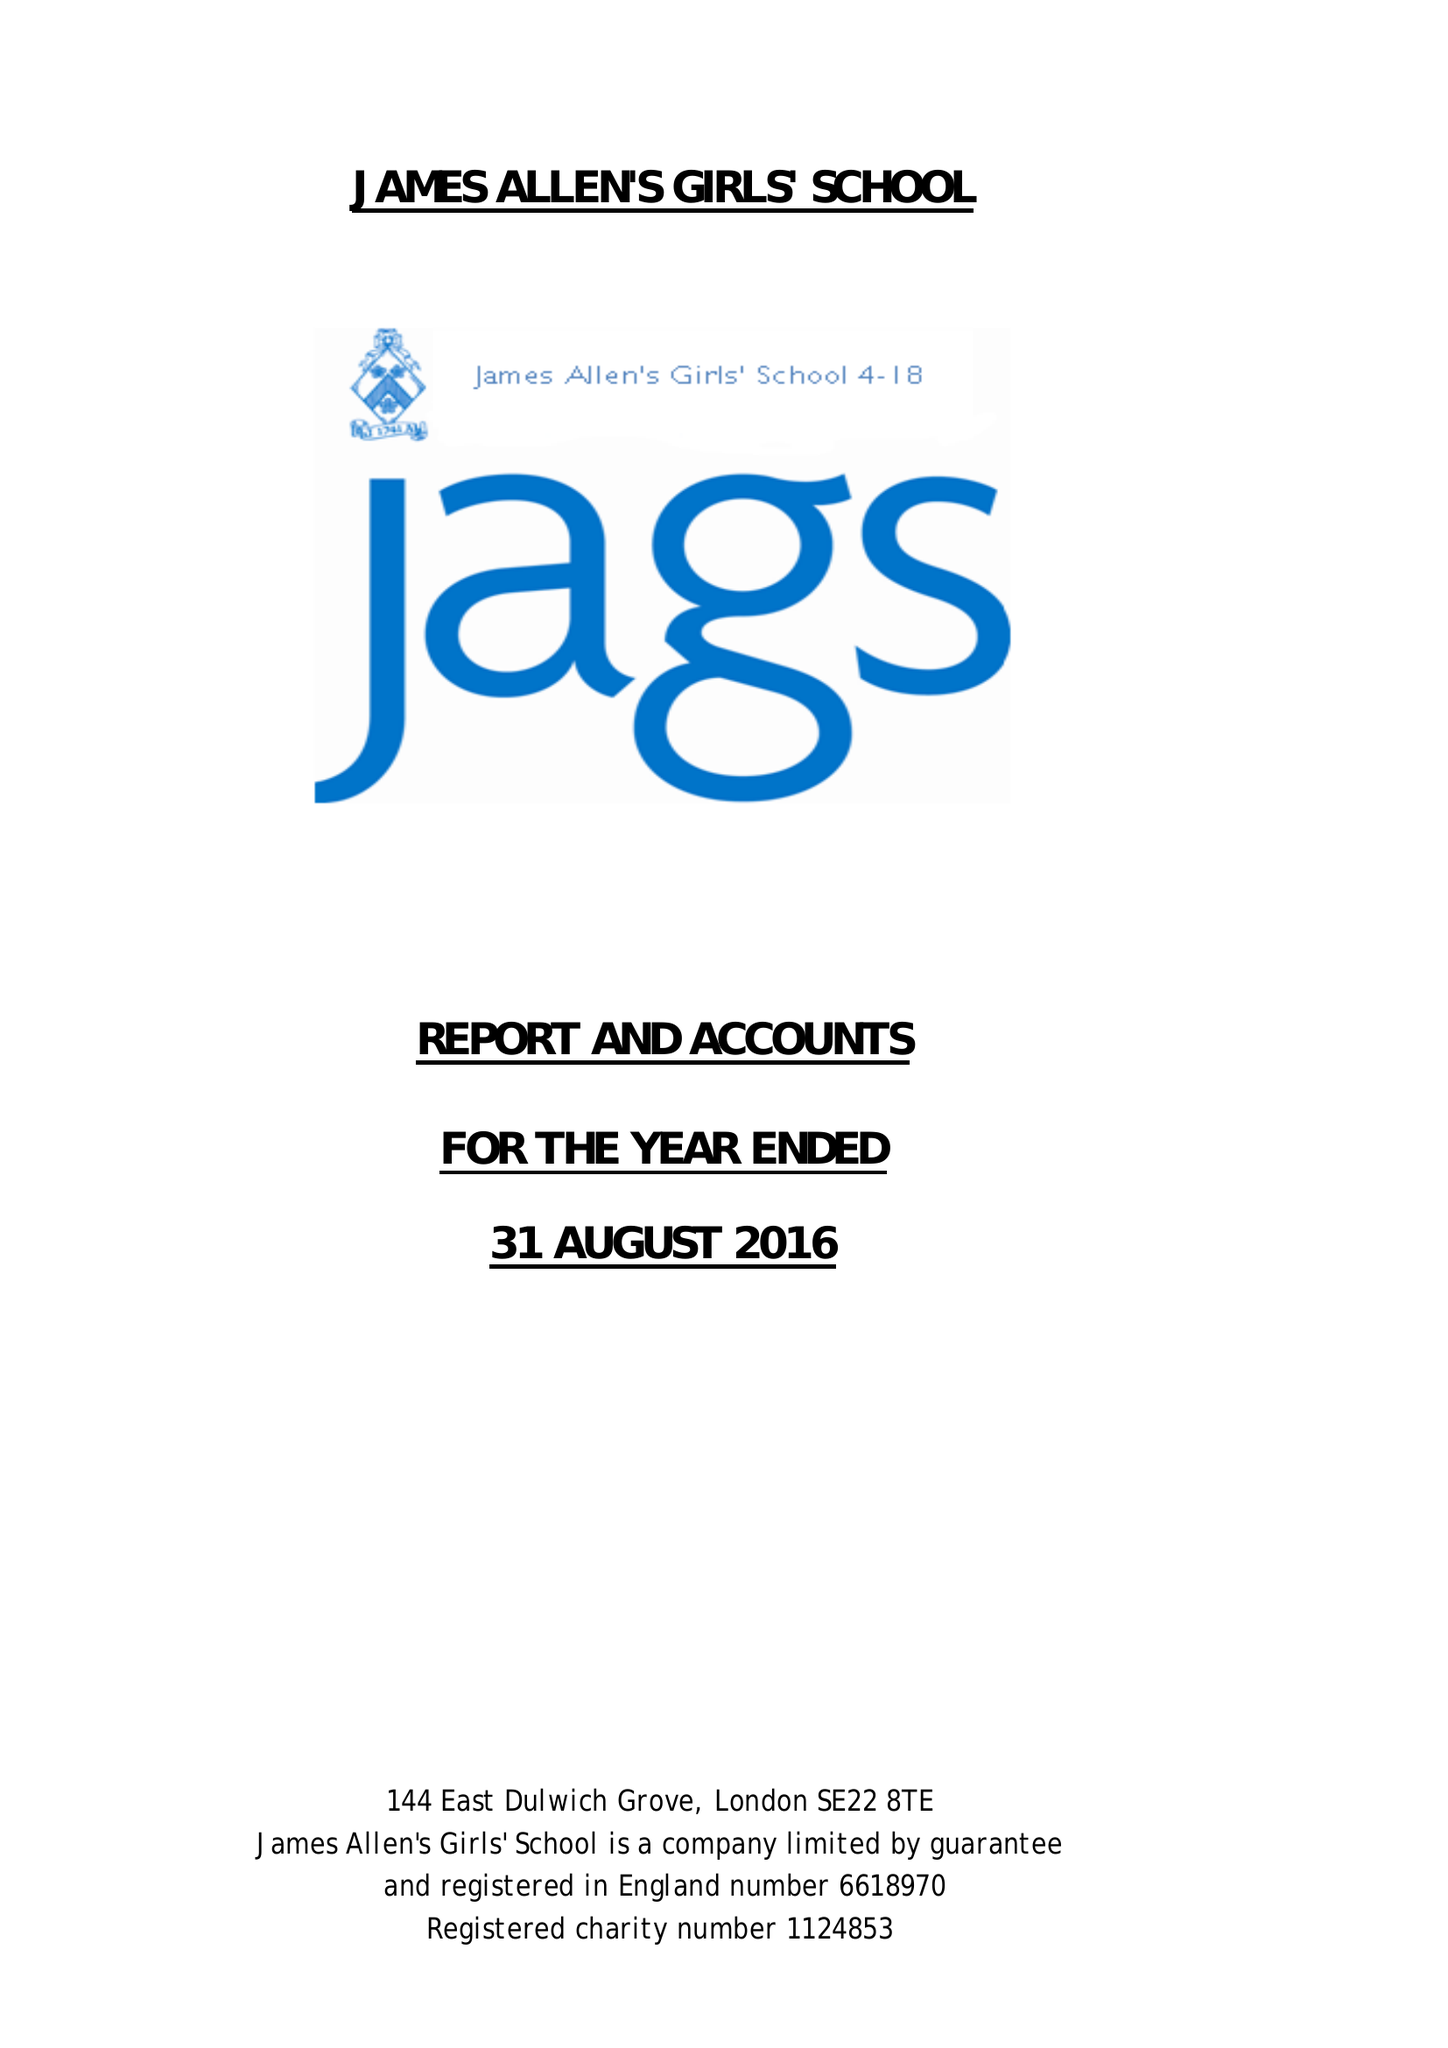What is the value for the charity_name?
Answer the question using a single word or phrase. James Allen's Girls' School 